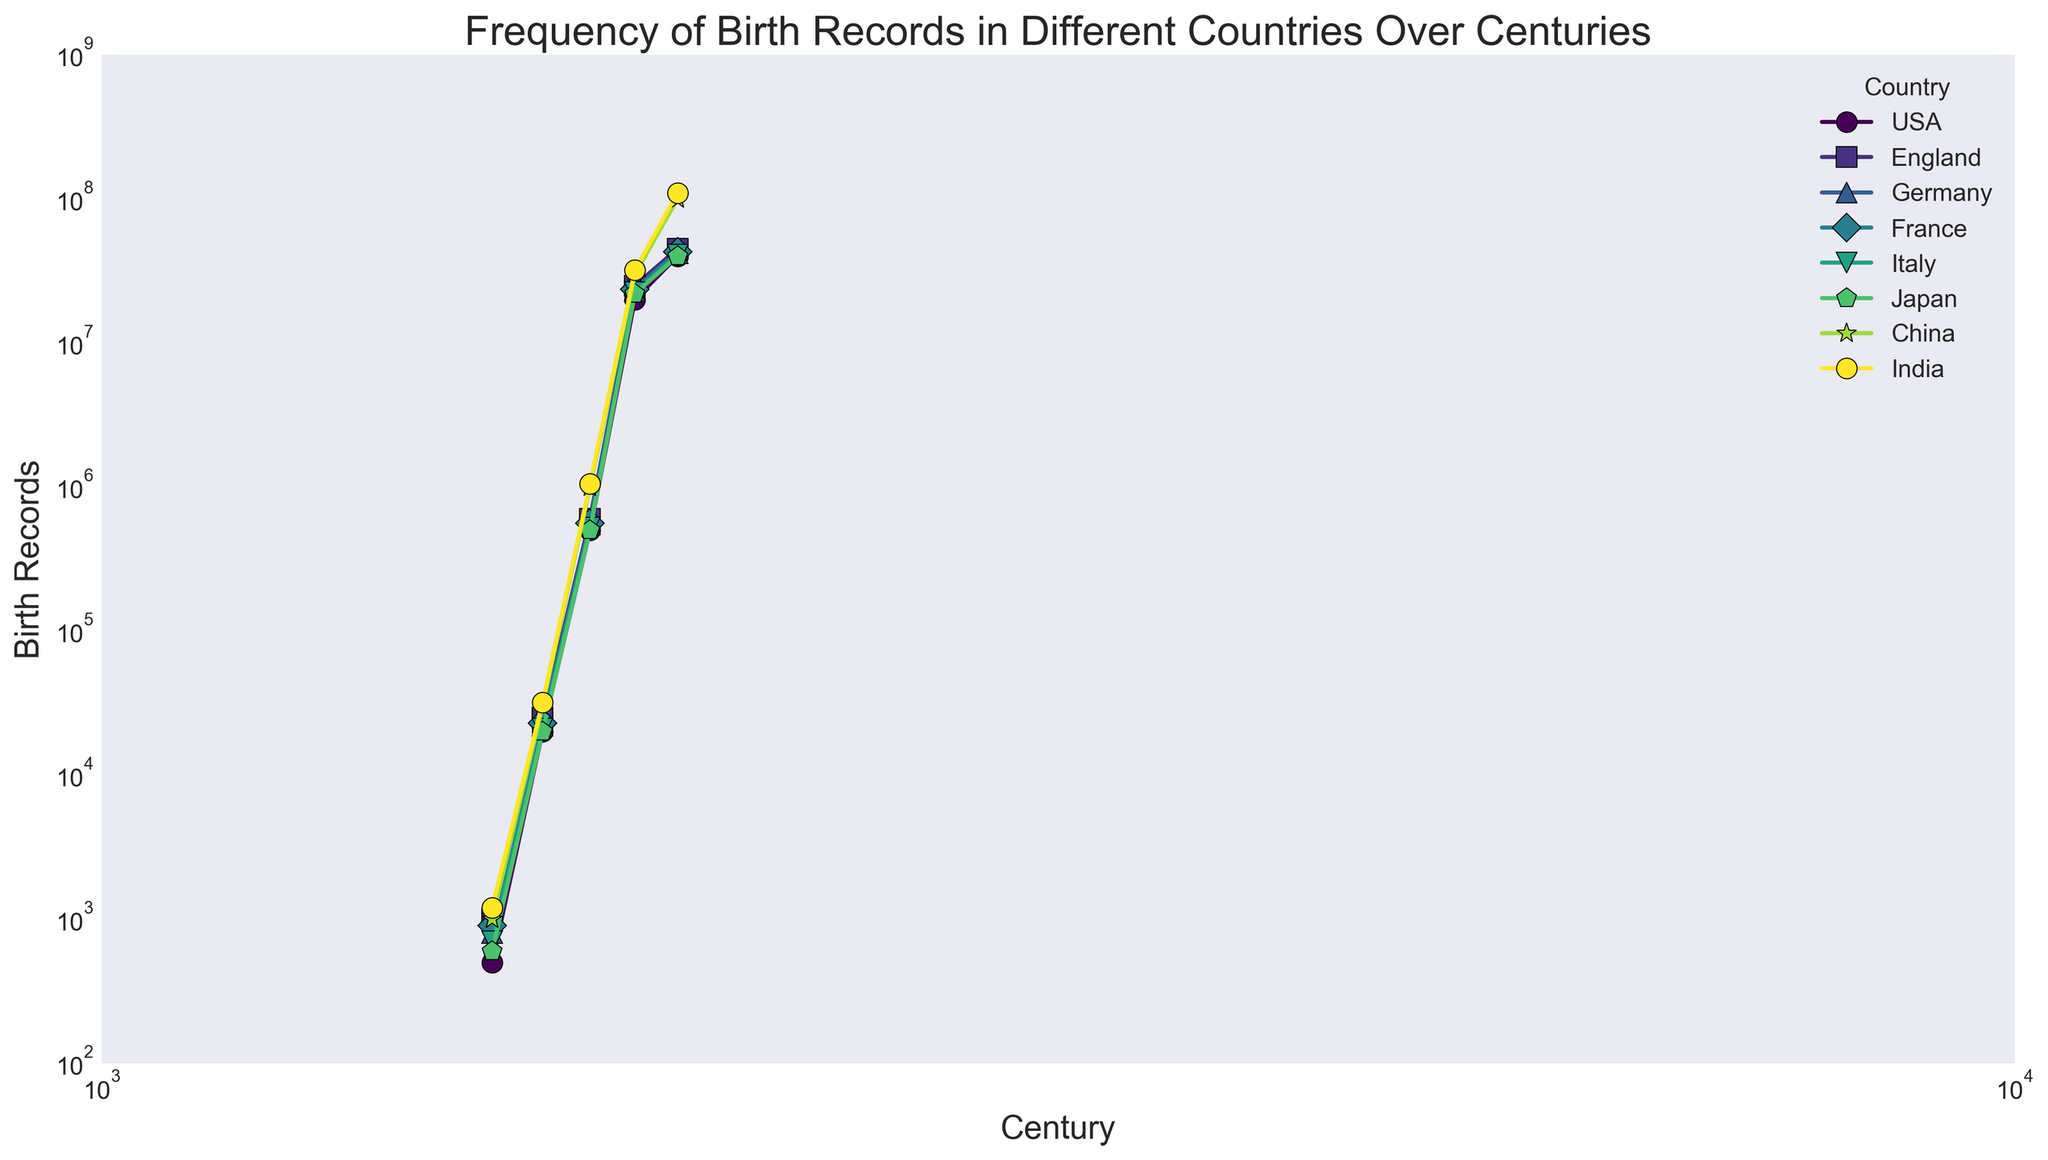What is the trend of birth records in the USA over the centuries? The x-axis represents the centuries, and the y-axis represents the number of birth records. Observing the plot for the USA, as the century progresses from 1600 to 2000, the number of birth records increases significantly. This pattern shows exponential growth over time.
Answer: Exponential growth Which country recorded the highest number of birth records in the 2000s? To answer this, observe the data points on the plot for the year 2000 and compare their y-values. India and China have the highest data points in the 2000s with both at 110,000,000.
Answer: India and China Compare the number of birth records in Germany and France in the year 1800. Which country has more? Locate the year 1800 on the x-axis for both Germany and France. Observe and compare their respective y-values. France has more birth records with 560,000 compared to Germany's 550,000.
Answer: France How does the frequency of birth records in India change from 1700 to 2000? Locate the data points for India at 1700 and 2000 and observe their y-values. There is a significant increase from 32,000 in 1700 to 110,000,000 in 2000. This indicates massive growth over the centuries.
Answer: Significant increase Which country shows the least number of birth records in the 1600s? Observe the data points for the year 1600 and identify the country with the lowest y-value. Japan has the least number of birth records in the 1600s with 600.
Answer: Japan Among USA, England, Germany, and France, which country had the most significant change in birth records between the 1800s and 1900s? Calculate the change for each country by subtracting their birth records in 1800 from 1900. The changes are: USA: 19,500,000; England: 24,400,000; Germany: 22,450,000; France: 23,900,000. England has the most significant change.
Answer: England What’s the average number of birth records in Japan over all centuries? Average is calculated by summing all birth record values for Japan and dividing by the number of centuries (5). (600 + 20000 + 500000 + 22000000 + 40000000) / 5 = 12,440,120.
Answer: 12,440,120 Do all the countries follow the same trend of increases in birth records over the centuries? By observing the plot, all countries show an increasing trend in the number of birth records over the centuries. The trend for all countries is similar with exponential growth observed.
Answer: Yes How does Italy's birth records in the 1700s compare to the birth records of the USA in the same century? Identify and compare the y-values for Italy and the USA in the 1700s. Italy has 21,000 whereas the USA has 20,000 birth records. Italy has slightly more birth records.
Answer: Italy Which two countries have the closest number of birth records in the year 1900? Observe the data points on the plot for the year 1900. Japan and Italy have birth records of 22,000,000 and 22,500,000 respectively, showing the closest values.
Answer: Japan and Italy 